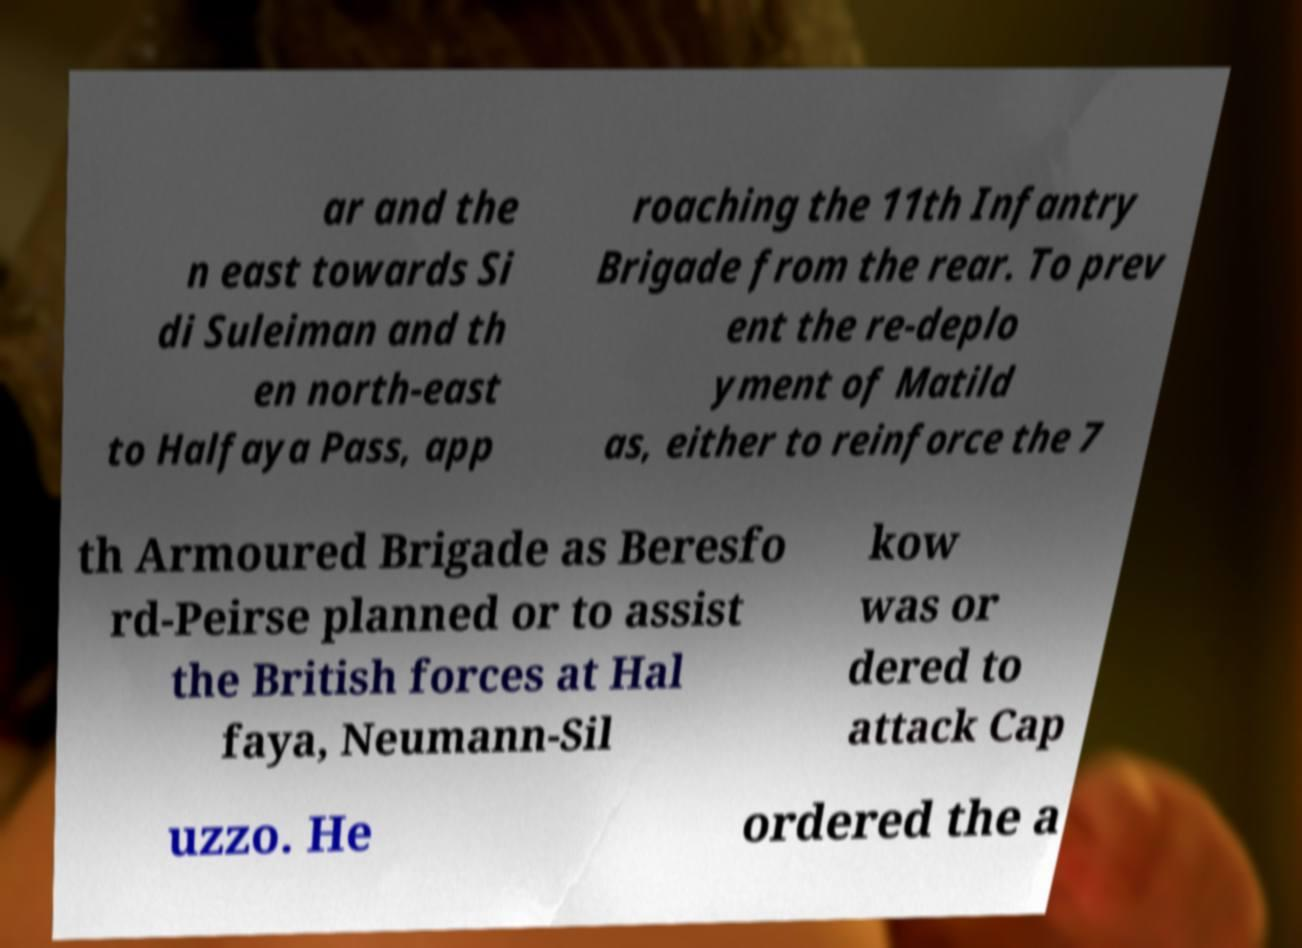I need the written content from this picture converted into text. Can you do that? ar and the n east towards Si di Suleiman and th en north-east to Halfaya Pass, app roaching the 11th Infantry Brigade from the rear. To prev ent the re-deplo yment of Matild as, either to reinforce the 7 th Armoured Brigade as Beresfo rd-Peirse planned or to assist the British forces at Hal faya, Neumann-Sil kow was or dered to attack Cap uzzo. He ordered the a 